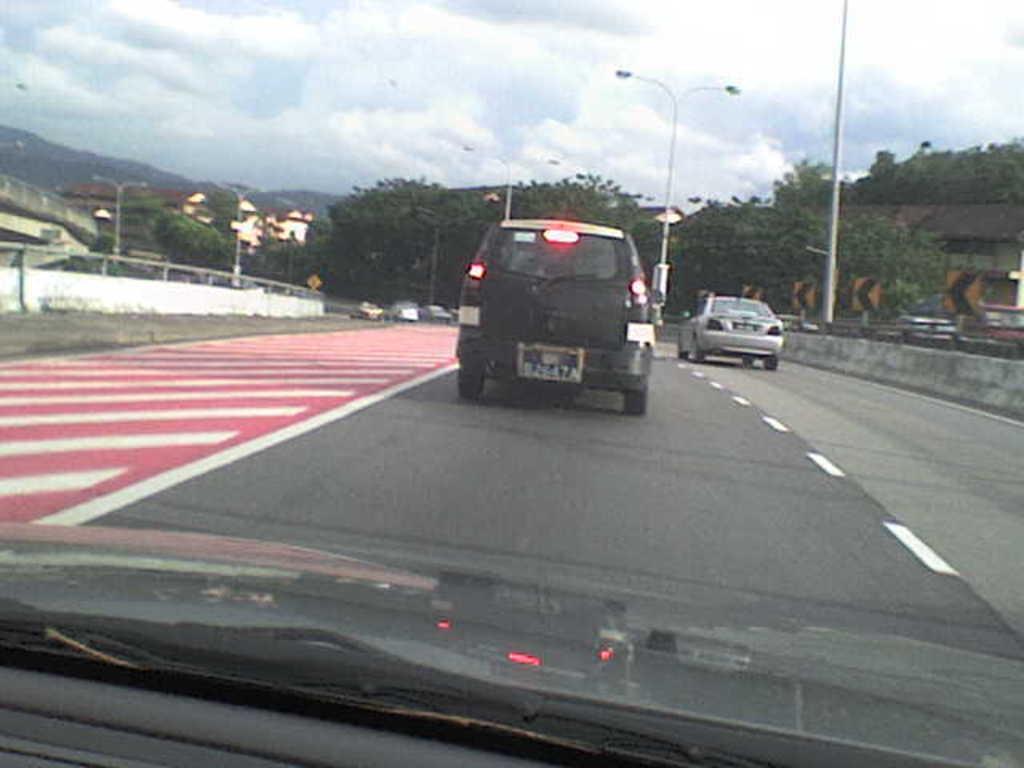Describe this image in one or two sentences. In the foreground of this image, there is a glass. Through the glass we can see few vehicles moving on the road and on either side, there are few poles, trees and sign boards. At the top, there is the sky. 